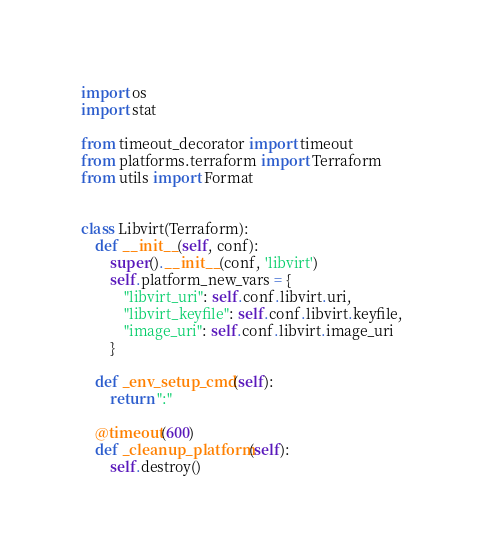<code> <loc_0><loc_0><loc_500><loc_500><_Python_>import os
import stat

from timeout_decorator import timeout
from platforms.terraform import Terraform
from utils import Format


class Libvirt(Terraform):
    def __init__(self, conf):
        super().__init__(conf, 'libvirt')
        self.platform_new_vars = {
            "libvirt_uri": self.conf.libvirt.uri,
            "libvirt_keyfile": self.conf.libvirt.keyfile,
            "image_uri": self.conf.libvirt.image_uri
        }

    def _env_setup_cmd(self):
        return ":"

    @timeout(600)
    def _cleanup_platform(self):
        self.destroy()
</code> 